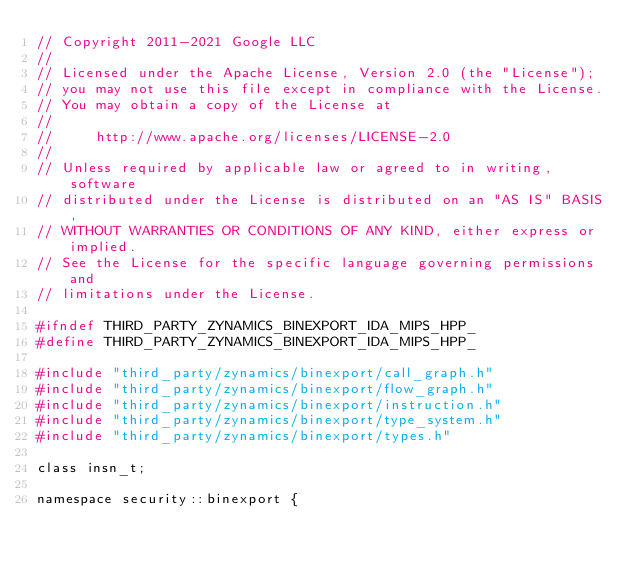<code> <loc_0><loc_0><loc_500><loc_500><_C_>// Copyright 2011-2021 Google LLC
//
// Licensed under the Apache License, Version 2.0 (the "License");
// you may not use this file except in compliance with the License.
// You may obtain a copy of the License at
//
//     http://www.apache.org/licenses/LICENSE-2.0
//
// Unless required by applicable law or agreed to in writing, software
// distributed under the License is distributed on an "AS IS" BASIS,
// WITHOUT WARRANTIES OR CONDITIONS OF ANY KIND, either express or implied.
// See the License for the specific language governing permissions and
// limitations under the License.

#ifndef THIRD_PARTY_ZYNAMICS_BINEXPORT_IDA_MIPS_HPP_
#define THIRD_PARTY_ZYNAMICS_BINEXPORT_IDA_MIPS_HPP_

#include "third_party/zynamics/binexport/call_graph.h"
#include "third_party/zynamics/binexport/flow_graph.h"
#include "third_party/zynamics/binexport/instruction.h"
#include "third_party/zynamics/binexport/type_system.h"
#include "third_party/zynamics/binexport/types.h"

class insn_t;

namespace security::binexport {
</code> 